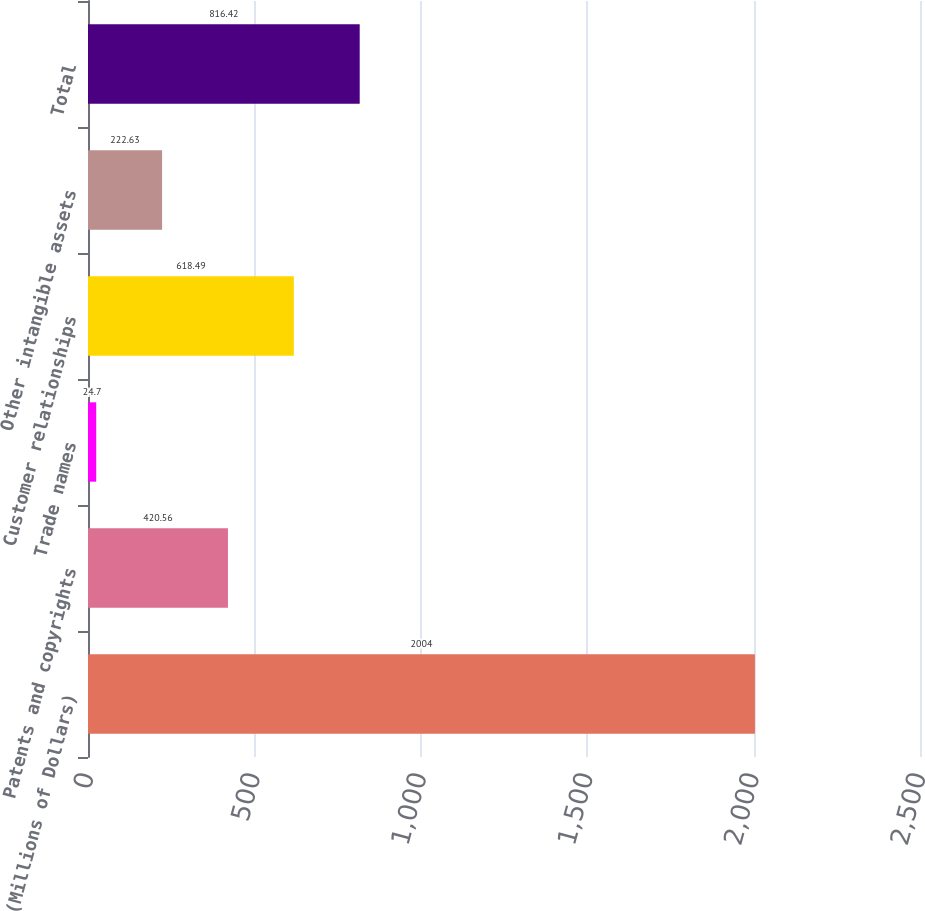<chart> <loc_0><loc_0><loc_500><loc_500><bar_chart><fcel>(Millions of Dollars)<fcel>Patents and copyrights<fcel>Trade names<fcel>Customer relationships<fcel>Other intangible assets<fcel>Total<nl><fcel>2004<fcel>420.56<fcel>24.7<fcel>618.49<fcel>222.63<fcel>816.42<nl></chart> 